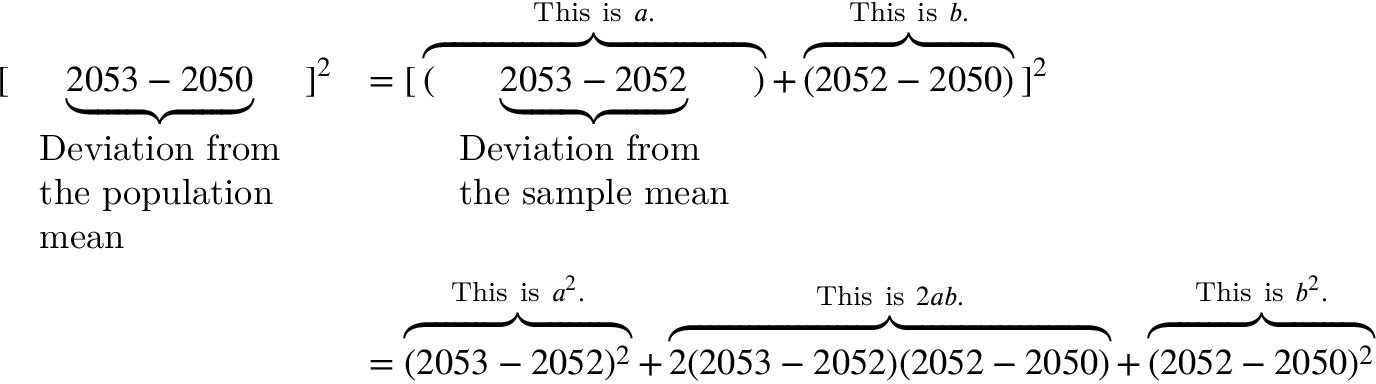<formula> <loc_0><loc_0><loc_500><loc_500>{ \begin{array} { r l } { { [ } \, \underbrace { 2 0 5 3 - 2 0 5 0 } _ { \begin{array} { l } { D e v i a t i o n f r o m } \\ { t h e p o p u l a t i o n } \\ { m e a n } \end{array} } \, ] ^ { 2 } } & { = [ \, \overbrace { ( \, \underbrace { 2 0 5 3 - 2 0 5 2 } _ { \begin{array} { l } { D e v i a t i o n f r o m } \\ { t h e s a m p l e m e a n } \end{array} } \, ) } ^ { { T h i s i s } a . } + \overbrace { ( 2 0 5 2 - 2 0 5 0 ) } ^ { { T h i s i s } b . } \, ] ^ { 2 } } \\ & { = \overbrace { ( 2 0 5 3 - 2 0 5 2 ) ^ { 2 } } ^ { { T h i s i s } a ^ { 2 } . } + \overbrace { 2 ( 2 0 5 3 - 2 0 5 2 ) ( 2 0 5 2 - 2 0 5 0 ) } ^ { { T h i s i s } 2 a b . } + \overbrace { ( 2 0 5 2 - 2 0 5 0 ) ^ { 2 } } ^ { { T h i s i s } b ^ { 2 } . } } \end{array} }</formula> 